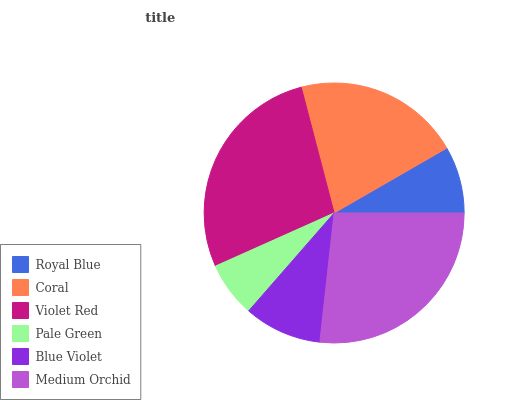Is Pale Green the minimum?
Answer yes or no. Yes. Is Violet Red the maximum?
Answer yes or no. Yes. Is Coral the minimum?
Answer yes or no. No. Is Coral the maximum?
Answer yes or no. No. Is Coral greater than Royal Blue?
Answer yes or no. Yes. Is Royal Blue less than Coral?
Answer yes or no. Yes. Is Royal Blue greater than Coral?
Answer yes or no. No. Is Coral less than Royal Blue?
Answer yes or no. No. Is Coral the high median?
Answer yes or no. Yes. Is Blue Violet the low median?
Answer yes or no. Yes. Is Royal Blue the high median?
Answer yes or no. No. Is Violet Red the low median?
Answer yes or no. No. 